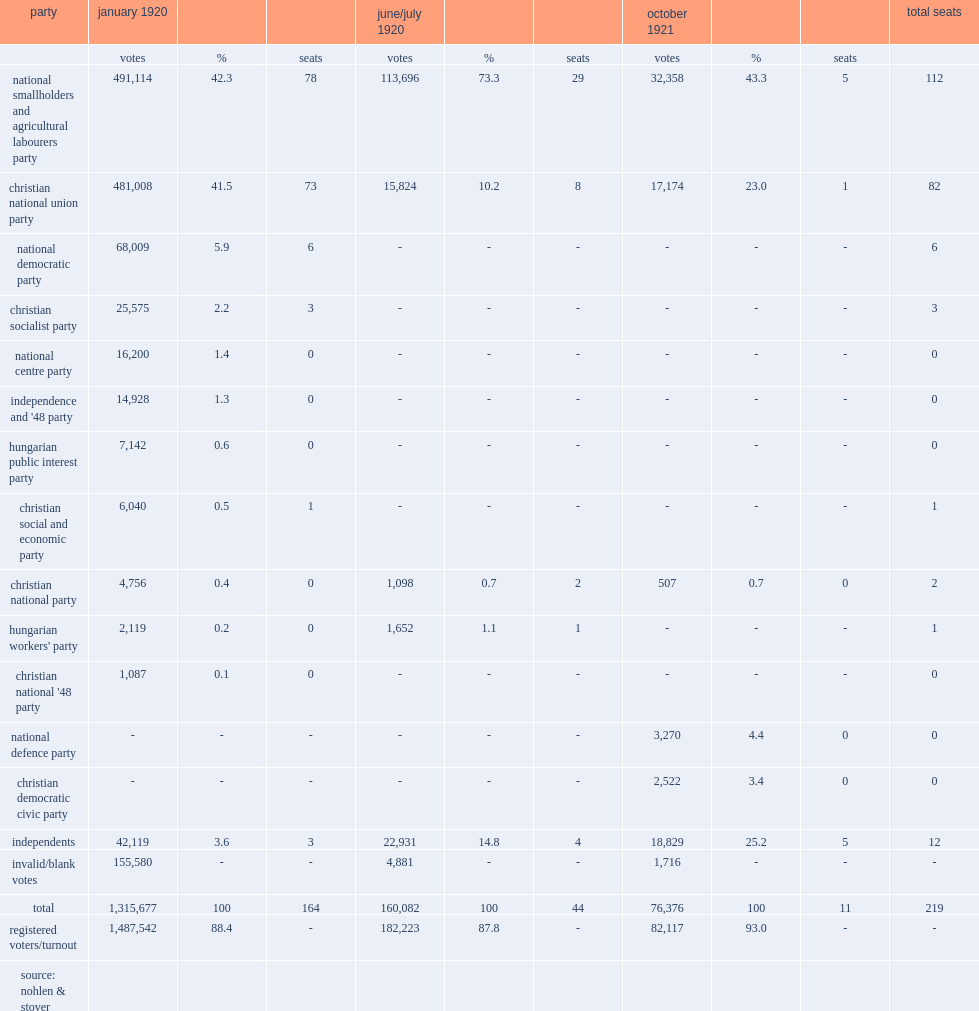How many seats did the national smallholders and agricultural labourers party and the christian national union party win totally? 194. 